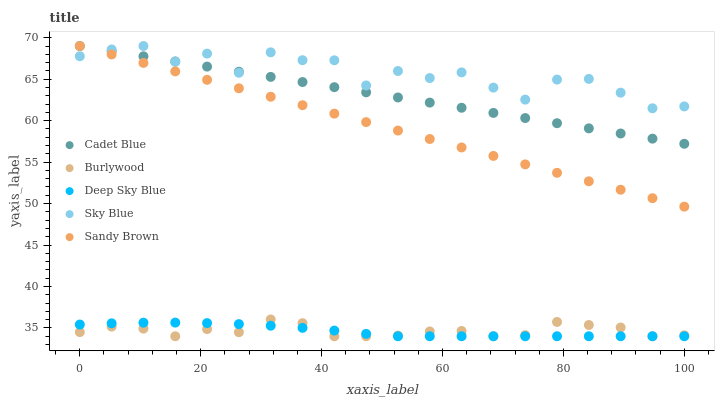Does Deep Sky Blue have the minimum area under the curve?
Answer yes or no. Yes. Does Sky Blue have the maximum area under the curve?
Answer yes or no. Yes. Does Cadet Blue have the minimum area under the curve?
Answer yes or no. No. Does Cadet Blue have the maximum area under the curve?
Answer yes or no. No. Is Cadet Blue the smoothest?
Answer yes or no. Yes. Is Sky Blue the roughest?
Answer yes or no. Yes. Is Sky Blue the smoothest?
Answer yes or no. No. Is Cadet Blue the roughest?
Answer yes or no. No. Does Burlywood have the lowest value?
Answer yes or no. Yes. Does Cadet Blue have the lowest value?
Answer yes or no. No. Does Sandy Brown have the highest value?
Answer yes or no. Yes. Does Deep Sky Blue have the highest value?
Answer yes or no. No. Is Deep Sky Blue less than Sandy Brown?
Answer yes or no. Yes. Is Sky Blue greater than Burlywood?
Answer yes or no. Yes. Does Cadet Blue intersect Sandy Brown?
Answer yes or no. Yes. Is Cadet Blue less than Sandy Brown?
Answer yes or no. No. Is Cadet Blue greater than Sandy Brown?
Answer yes or no. No. Does Deep Sky Blue intersect Sandy Brown?
Answer yes or no. No. 